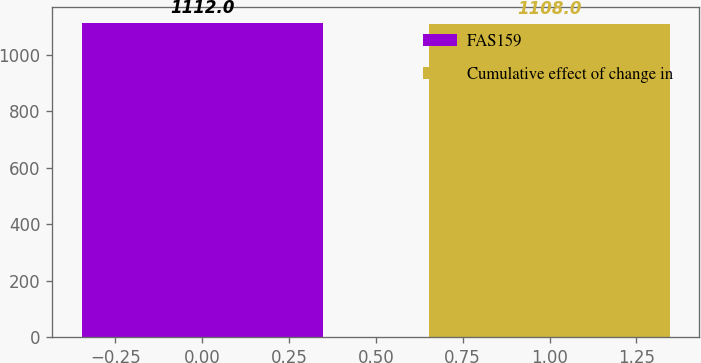Convert chart to OTSL. <chart><loc_0><loc_0><loc_500><loc_500><bar_chart><fcel>FAS159<fcel>Cumulative effect of change in<nl><fcel>1112<fcel>1108<nl></chart> 